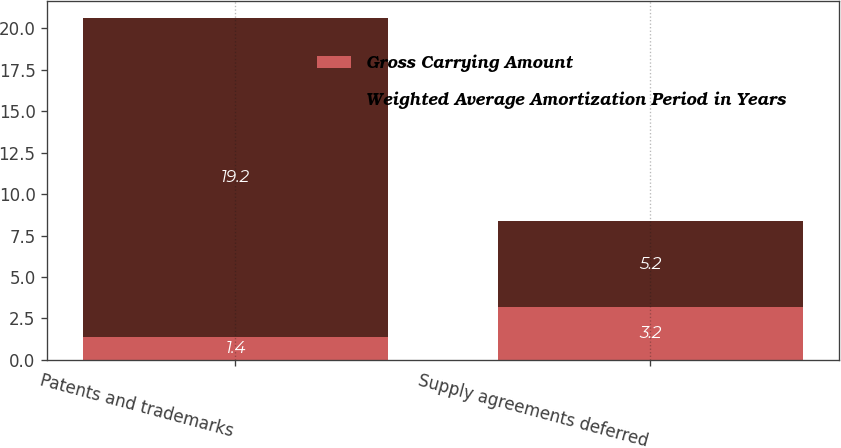Convert chart to OTSL. <chart><loc_0><loc_0><loc_500><loc_500><stacked_bar_chart><ecel><fcel>Patents and trademarks<fcel>Supply agreements deferred<nl><fcel>Gross Carrying Amount<fcel>1.4<fcel>3.2<nl><fcel>Weighted Average Amortization Period in Years<fcel>19.2<fcel>5.2<nl></chart> 